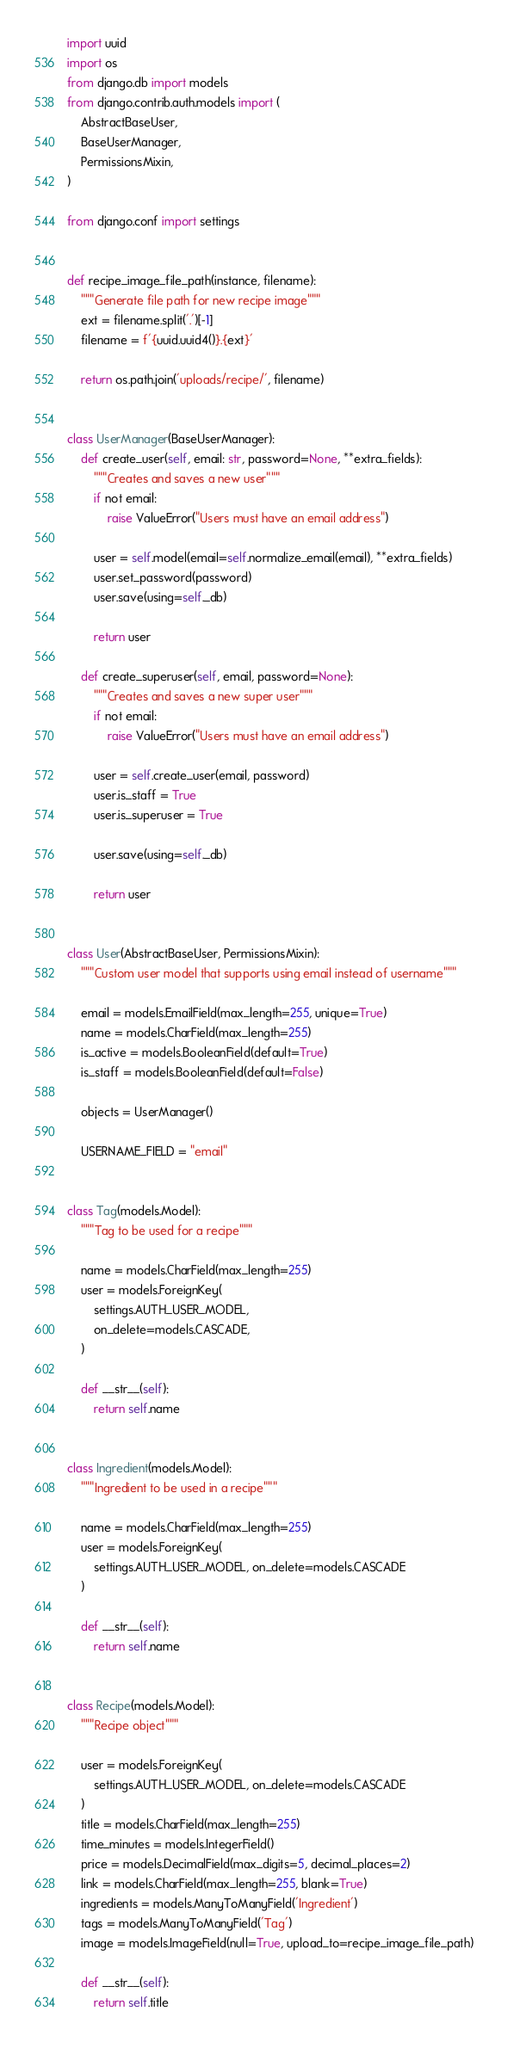<code> <loc_0><loc_0><loc_500><loc_500><_Python_>import uuid
import os
from django.db import models
from django.contrib.auth.models import (
    AbstractBaseUser,
    BaseUserManager,
    PermissionsMixin,
)

from django.conf import settings


def recipe_image_file_path(instance, filename):
    """Generate file path for new recipe image"""
    ext = filename.split('.')[-1]
    filename = f'{uuid.uuid4()}.{ext}'

    return os.path.join('uploads/recipe/', filename)


class UserManager(BaseUserManager):
    def create_user(self, email: str, password=None, **extra_fields):
        """Creates and saves a new user"""
        if not email:
            raise ValueError("Users must have an email address")

        user = self.model(email=self.normalize_email(email), **extra_fields)
        user.set_password(password)
        user.save(using=self._db)

        return user

    def create_superuser(self, email, password=None):
        """Creates and saves a new super user"""
        if not email:
            raise ValueError("Users must have an email address")

        user = self.create_user(email, password)
        user.is_staff = True
        user.is_superuser = True

        user.save(using=self._db)

        return user


class User(AbstractBaseUser, PermissionsMixin):
    """Custom user model that supports using email instead of username"""

    email = models.EmailField(max_length=255, unique=True)
    name = models.CharField(max_length=255)
    is_active = models.BooleanField(default=True)
    is_staff = models.BooleanField(default=False)

    objects = UserManager()

    USERNAME_FIELD = "email"


class Tag(models.Model):
    """Tag to be used for a recipe"""

    name = models.CharField(max_length=255)
    user = models.ForeignKey(
        settings.AUTH_USER_MODEL,
        on_delete=models.CASCADE,
    )

    def __str__(self):
        return self.name


class Ingredient(models.Model):
    """Ingredient to be used in a recipe"""

    name = models.CharField(max_length=255)
    user = models.ForeignKey(
        settings.AUTH_USER_MODEL, on_delete=models.CASCADE
    )

    def __str__(self):
        return self.name


class Recipe(models.Model):
    """Recipe object"""

    user = models.ForeignKey(
        settings.AUTH_USER_MODEL, on_delete=models.CASCADE
    )
    title = models.CharField(max_length=255)
    time_minutes = models.IntegerField()
    price = models.DecimalField(max_digits=5, decimal_places=2)
    link = models.CharField(max_length=255, blank=True)
    ingredients = models.ManyToManyField('Ingredient')
    tags = models.ManyToManyField('Tag')
    image = models.ImageField(null=True, upload_to=recipe_image_file_path)

    def __str__(self):
        return self.title
</code> 